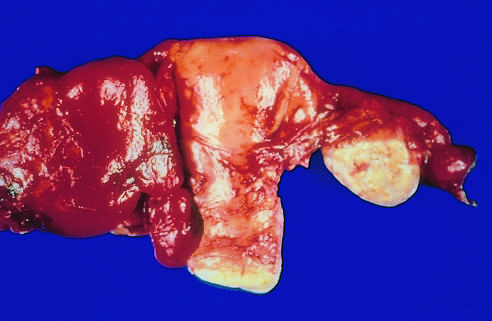re edema totally obscured by a hemorrhagic inflammatory mass?
Answer the question using a single word or phrase. No 